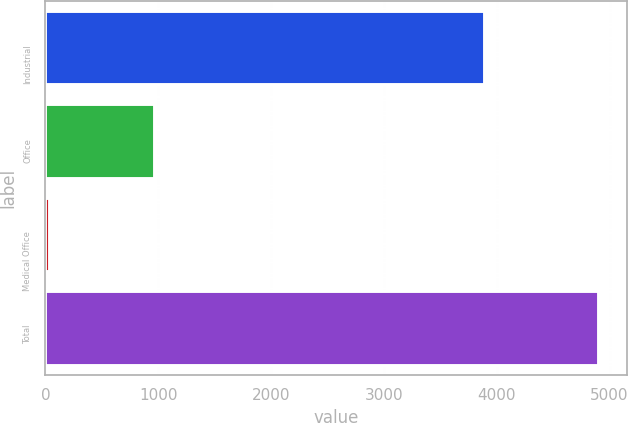Convert chart. <chart><loc_0><loc_0><loc_500><loc_500><bar_chart><fcel>Industrial<fcel>Office<fcel>Medical Office<fcel>Total<nl><fcel>3900<fcel>972<fcel>39<fcel>4911<nl></chart> 